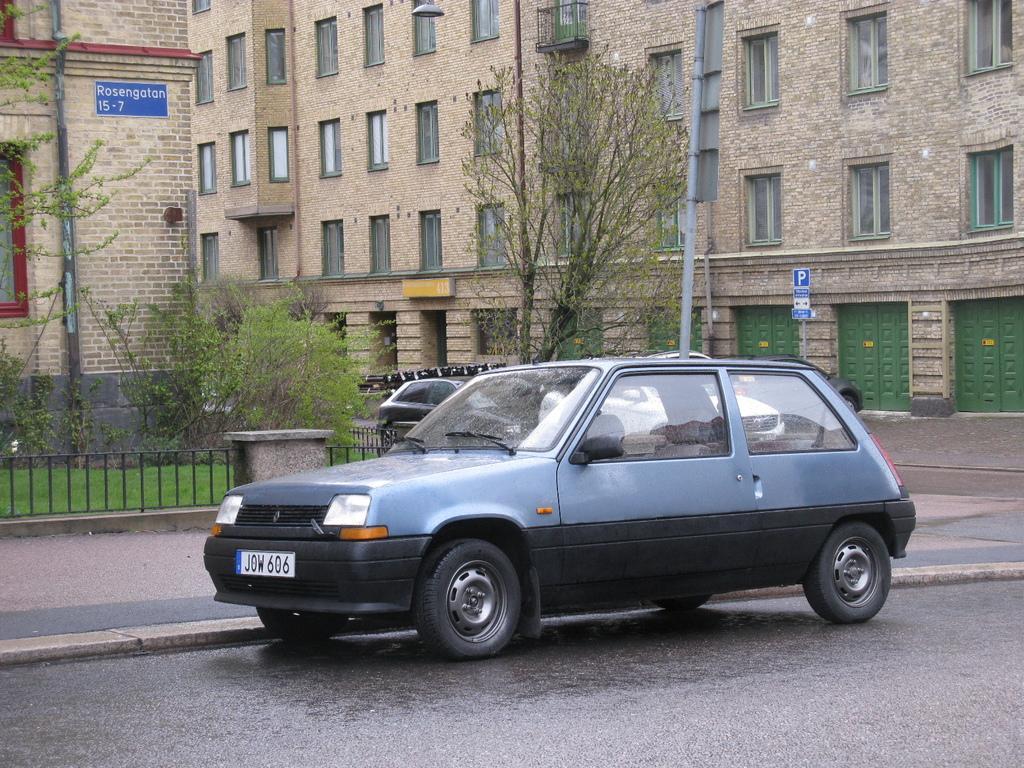Describe this image in one or two sentences. In this image we can see a few cars on the road, there are trees, two buildings, an iron railing, a sign board, poles with board and there are windows and doors to the building. 